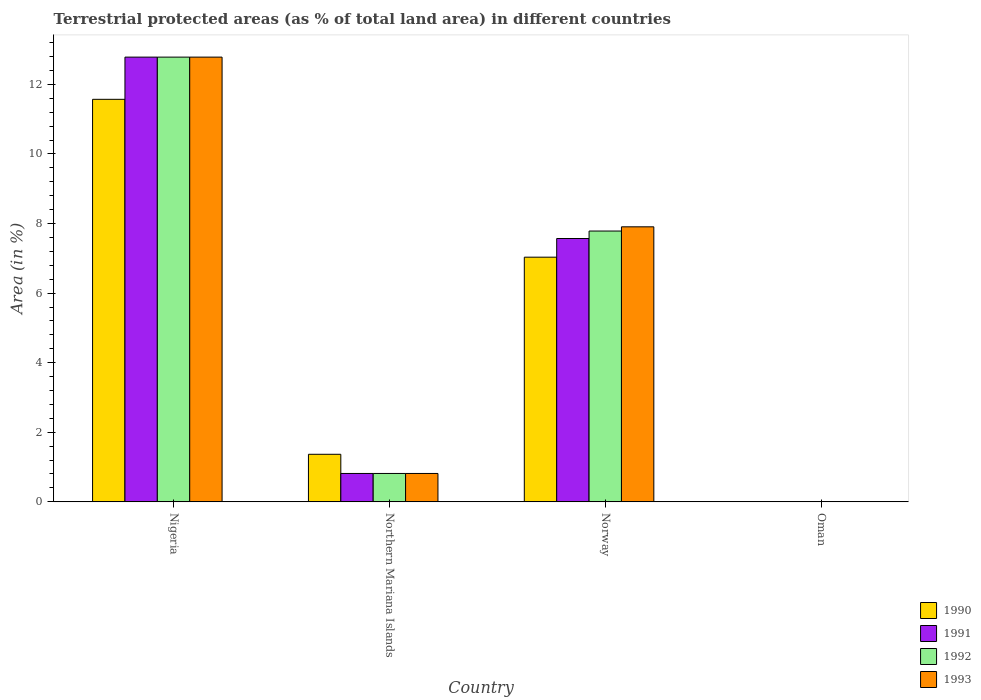How many groups of bars are there?
Keep it short and to the point. 4. Are the number of bars per tick equal to the number of legend labels?
Your response must be concise. Yes. What is the label of the 4th group of bars from the left?
Provide a short and direct response. Oman. What is the percentage of terrestrial protected land in 1992 in Northern Mariana Islands?
Provide a succinct answer. 0.82. Across all countries, what is the maximum percentage of terrestrial protected land in 1991?
Your response must be concise. 12.78. Across all countries, what is the minimum percentage of terrestrial protected land in 1990?
Your answer should be very brief. 0. In which country was the percentage of terrestrial protected land in 1991 maximum?
Give a very brief answer. Nigeria. In which country was the percentage of terrestrial protected land in 1991 minimum?
Offer a very short reply. Oman. What is the total percentage of terrestrial protected land in 1991 in the graph?
Give a very brief answer. 21.17. What is the difference between the percentage of terrestrial protected land in 1992 in Norway and that in Oman?
Offer a very short reply. 7.78. What is the difference between the percentage of terrestrial protected land in 1993 in Oman and the percentage of terrestrial protected land in 1992 in Northern Mariana Islands?
Offer a very short reply. -0.81. What is the average percentage of terrestrial protected land in 1991 per country?
Your response must be concise. 5.29. What is the difference between the percentage of terrestrial protected land of/in 1991 and percentage of terrestrial protected land of/in 1993 in Norway?
Provide a short and direct response. -0.34. In how many countries, is the percentage of terrestrial protected land in 1993 greater than 1.2000000000000002 %?
Make the answer very short. 2. What is the ratio of the percentage of terrestrial protected land in 1991 in Northern Mariana Islands to that in Oman?
Ensure brevity in your answer.  508.17. What is the difference between the highest and the second highest percentage of terrestrial protected land in 1993?
Offer a terse response. -11.97. What is the difference between the highest and the lowest percentage of terrestrial protected land in 1993?
Provide a succinct answer. 12.78. What does the 1st bar from the left in Oman represents?
Offer a very short reply. 1990. What does the 2nd bar from the right in Nigeria represents?
Your answer should be very brief. 1992. How many bars are there?
Your answer should be very brief. 16. Are all the bars in the graph horizontal?
Give a very brief answer. No. How many countries are there in the graph?
Keep it short and to the point. 4. Does the graph contain grids?
Keep it short and to the point. No. How many legend labels are there?
Offer a terse response. 4. How are the legend labels stacked?
Offer a very short reply. Vertical. What is the title of the graph?
Provide a short and direct response. Terrestrial protected areas (as % of total land area) in different countries. Does "1973" appear as one of the legend labels in the graph?
Your response must be concise. No. What is the label or title of the Y-axis?
Ensure brevity in your answer.  Area (in %). What is the Area (in %) in 1990 in Nigeria?
Offer a terse response. 11.57. What is the Area (in %) of 1991 in Nigeria?
Offer a very short reply. 12.78. What is the Area (in %) in 1992 in Nigeria?
Your answer should be very brief. 12.78. What is the Area (in %) of 1993 in Nigeria?
Offer a very short reply. 12.78. What is the Area (in %) of 1990 in Northern Mariana Islands?
Your response must be concise. 1.37. What is the Area (in %) in 1991 in Northern Mariana Islands?
Provide a succinct answer. 0.82. What is the Area (in %) in 1992 in Northern Mariana Islands?
Your answer should be very brief. 0.82. What is the Area (in %) of 1993 in Northern Mariana Islands?
Ensure brevity in your answer.  0.82. What is the Area (in %) in 1990 in Norway?
Make the answer very short. 7.03. What is the Area (in %) in 1991 in Norway?
Your answer should be compact. 7.57. What is the Area (in %) of 1992 in Norway?
Give a very brief answer. 7.78. What is the Area (in %) of 1993 in Norway?
Your answer should be compact. 7.9. What is the Area (in %) of 1990 in Oman?
Keep it short and to the point. 0. What is the Area (in %) in 1991 in Oman?
Offer a very short reply. 0. What is the Area (in %) in 1992 in Oman?
Your answer should be compact. 0. What is the Area (in %) of 1993 in Oman?
Ensure brevity in your answer.  0. Across all countries, what is the maximum Area (in %) of 1990?
Ensure brevity in your answer.  11.57. Across all countries, what is the maximum Area (in %) in 1991?
Your response must be concise. 12.78. Across all countries, what is the maximum Area (in %) of 1992?
Your answer should be compact. 12.78. Across all countries, what is the maximum Area (in %) of 1993?
Make the answer very short. 12.78. Across all countries, what is the minimum Area (in %) in 1990?
Offer a terse response. 0. Across all countries, what is the minimum Area (in %) in 1991?
Provide a short and direct response. 0. Across all countries, what is the minimum Area (in %) of 1992?
Keep it short and to the point. 0. Across all countries, what is the minimum Area (in %) in 1993?
Ensure brevity in your answer.  0. What is the total Area (in %) in 1990 in the graph?
Make the answer very short. 19.97. What is the total Area (in %) in 1991 in the graph?
Give a very brief answer. 21.17. What is the total Area (in %) of 1992 in the graph?
Your answer should be compact. 21.38. What is the total Area (in %) in 1993 in the graph?
Offer a terse response. 21.5. What is the difference between the Area (in %) in 1990 in Nigeria and that in Northern Mariana Islands?
Make the answer very short. 10.2. What is the difference between the Area (in %) of 1991 in Nigeria and that in Northern Mariana Islands?
Your answer should be compact. 11.97. What is the difference between the Area (in %) of 1992 in Nigeria and that in Northern Mariana Islands?
Ensure brevity in your answer.  11.97. What is the difference between the Area (in %) of 1993 in Nigeria and that in Northern Mariana Islands?
Ensure brevity in your answer.  11.97. What is the difference between the Area (in %) of 1990 in Nigeria and that in Norway?
Your response must be concise. 4.54. What is the difference between the Area (in %) of 1991 in Nigeria and that in Norway?
Make the answer very short. 5.21. What is the difference between the Area (in %) in 1992 in Nigeria and that in Norway?
Provide a short and direct response. 5. What is the difference between the Area (in %) in 1993 in Nigeria and that in Norway?
Offer a very short reply. 4.88. What is the difference between the Area (in %) in 1990 in Nigeria and that in Oman?
Provide a succinct answer. 11.57. What is the difference between the Area (in %) in 1991 in Nigeria and that in Oman?
Make the answer very short. 12.78. What is the difference between the Area (in %) in 1992 in Nigeria and that in Oman?
Ensure brevity in your answer.  12.78. What is the difference between the Area (in %) in 1993 in Nigeria and that in Oman?
Your response must be concise. 12.78. What is the difference between the Area (in %) in 1990 in Northern Mariana Islands and that in Norway?
Your answer should be compact. -5.67. What is the difference between the Area (in %) of 1991 in Northern Mariana Islands and that in Norway?
Offer a terse response. -6.75. What is the difference between the Area (in %) in 1992 in Northern Mariana Islands and that in Norway?
Your answer should be very brief. -6.97. What is the difference between the Area (in %) of 1993 in Northern Mariana Islands and that in Norway?
Give a very brief answer. -7.09. What is the difference between the Area (in %) of 1990 in Northern Mariana Islands and that in Oman?
Your response must be concise. 1.36. What is the difference between the Area (in %) in 1991 in Northern Mariana Islands and that in Oman?
Keep it short and to the point. 0.81. What is the difference between the Area (in %) in 1992 in Northern Mariana Islands and that in Oman?
Ensure brevity in your answer.  0.81. What is the difference between the Area (in %) in 1993 in Northern Mariana Islands and that in Oman?
Provide a short and direct response. 0.81. What is the difference between the Area (in %) in 1990 in Norway and that in Oman?
Offer a terse response. 7.03. What is the difference between the Area (in %) of 1991 in Norway and that in Oman?
Provide a short and direct response. 7.57. What is the difference between the Area (in %) in 1992 in Norway and that in Oman?
Make the answer very short. 7.78. What is the difference between the Area (in %) in 1993 in Norway and that in Oman?
Offer a very short reply. 7.9. What is the difference between the Area (in %) in 1990 in Nigeria and the Area (in %) in 1991 in Northern Mariana Islands?
Ensure brevity in your answer.  10.75. What is the difference between the Area (in %) of 1990 in Nigeria and the Area (in %) of 1992 in Northern Mariana Islands?
Your response must be concise. 10.75. What is the difference between the Area (in %) of 1990 in Nigeria and the Area (in %) of 1993 in Northern Mariana Islands?
Offer a very short reply. 10.75. What is the difference between the Area (in %) of 1991 in Nigeria and the Area (in %) of 1992 in Northern Mariana Islands?
Keep it short and to the point. 11.97. What is the difference between the Area (in %) of 1991 in Nigeria and the Area (in %) of 1993 in Northern Mariana Islands?
Give a very brief answer. 11.97. What is the difference between the Area (in %) of 1992 in Nigeria and the Area (in %) of 1993 in Northern Mariana Islands?
Provide a short and direct response. 11.97. What is the difference between the Area (in %) in 1990 in Nigeria and the Area (in %) in 1991 in Norway?
Provide a short and direct response. 4. What is the difference between the Area (in %) in 1990 in Nigeria and the Area (in %) in 1992 in Norway?
Your response must be concise. 3.79. What is the difference between the Area (in %) of 1990 in Nigeria and the Area (in %) of 1993 in Norway?
Ensure brevity in your answer.  3.66. What is the difference between the Area (in %) of 1991 in Nigeria and the Area (in %) of 1992 in Norway?
Offer a very short reply. 5. What is the difference between the Area (in %) of 1991 in Nigeria and the Area (in %) of 1993 in Norway?
Ensure brevity in your answer.  4.88. What is the difference between the Area (in %) of 1992 in Nigeria and the Area (in %) of 1993 in Norway?
Keep it short and to the point. 4.88. What is the difference between the Area (in %) of 1990 in Nigeria and the Area (in %) of 1991 in Oman?
Provide a succinct answer. 11.57. What is the difference between the Area (in %) in 1990 in Nigeria and the Area (in %) in 1992 in Oman?
Give a very brief answer. 11.57. What is the difference between the Area (in %) of 1990 in Nigeria and the Area (in %) of 1993 in Oman?
Offer a terse response. 11.57. What is the difference between the Area (in %) in 1991 in Nigeria and the Area (in %) in 1992 in Oman?
Provide a short and direct response. 12.78. What is the difference between the Area (in %) of 1991 in Nigeria and the Area (in %) of 1993 in Oman?
Give a very brief answer. 12.78. What is the difference between the Area (in %) of 1992 in Nigeria and the Area (in %) of 1993 in Oman?
Your answer should be very brief. 12.78. What is the difference between the Area (in %) in 1990 in Northern Mariana Islands and the Area (in %) in 1991 in Norway?
Provide a short and direct response. -6.2. What is the difference between the Area (in %) in 1990 in Northern Mariana Islands and the Area (in %) in 1992 in Norway?
Keep it short and to the point. -6.42. What is the difference between the Area (in %) of 1990 in Northern Mariana Islands and the Area (in %) of 1993 in Norway?
Provide a short and direct response. -6.54. What is the difference between the Area (in %) in 1991 in Northern Mariana Islands and the Area (in %) in 1992 in Norway?
Your answer should be very brief. -6.97. What is the difference between the Area (in %) of 1991 in Northern Mariana Islands and the Area (in %) of 1993 in Norway?
Your response must be concise. -7.09. What is the difference between the Area (in %) in 1992 in Northern Mariana Islands and the Area (in %) in 1993 in Norway?
Ensure brevity in your answer.  -7.09. What is the difference between the Area (in %) of 1990 in Northern Mariana Islands and the Area (in %) of 1991 in Oman?
Ensure brevity in your answer.  1.36. What is the difference between the Area (in %) in 1990 in Northern Mariana Islands and the Area (in %) in 1992 in Oman?
Offer a very short reply. 1.36. What is the difference between the Area (in %) in 1990 in Northern Mariana Islands and the Area (in %) in 1993 in Oman?
Your answer should be compact. 1.36. What is the difference between the Area (in %) of 1991 in Northern Mariana Islands and the Area (in %) of 1992 in Oman?
Offer a very short reply. 0.81. What is the difference between the Area (in %) in 1991 in Northern Mariana Islands and the Area (in %) in 1993 in Oman?
Offer a terse response. 0.81. What is the difference between the Area (in %) in 1992 in Northern Mariana Islands and the Area (in %) in 1993 in Oman?
Your response must be concise. 0.81. What is the difference between the Area (in %) in 1990 in Norway and the Area (in %) in 1991 in Oman?
Offer a terse response. 7.03. What is the difference between the Area (in %) of 1990 in Norway and the Area (in %) of 1992 in Oman?
Offer a terse response. 7.03. What is the difference between the Area (in %) in 1990 in Norway and the Area (in %) in 1993 in Oman?
Give a very brief answer. 7.03. What is the difference between the Area (in %) of 1991 in Norway and the Area (in %) of 1992 in Oman?
Your response must be concise. 7.57. What is the difference between the Area (in %) in 1991 in Norway and the Area (in %) in 1993 in Oman?
Offer a very short reply. 7.57. What is the difference between the Area (in %) in 1992 in Norway and the Area (in %) in 1993 in Oman?
Provide a succinct answer. 7.78. What is the average Area (in %) of 1990 per country?
Your answer should be compact. 4.99. What is the average Area (in %) of 1991 per country?
Offer a terse response. 5.29. What is the average Area (in %) of 1992 per country?
Your answer should be very brief. 5.35. What is the average Area (in %) in 1993 per country?
Give a very brief answer. 5.38. What is the difference between the Area (in %) of 1990 and Area (in %) of 1991 in Nigeria?
Make the answer very short. -1.21. What is the difference between the Area (in %) of 1990 and Area (in %) of 1992 in Nigeria?
Keep it short and to the point. -1.21. What is the difference between the Area (in %) of 1990 and Area (in %) of 1993 in Nigeria?
Your answer should be very brief. -1.21. What is the difference between the Area (in %) in 1991 and Area (in %) in 1993 in Nigeria?
Offer a very short reply. 0. What is the difference between the Area (in %) of 1990 and Area (in %) of 1991 in Northern Mariana Islands?
Offer a terse response. 0.55. What is the difference between the Area (in %) of 1990 and Area (in %) of 1992 in Northern Mariana Islands?
Ensure brevity in your answer.  0.55. What is the difference between the Area (in %) of 1990 and Area (in %) of 1993 in Northern Mariana Islands?
Offer a very short reply. 0.55. What is the difference between the Area (in %) of 1991 and Area (in %) of 1993 in Northern Mariana Islands?
Your answer should be very brief. 0. What is the difference between the Area (in %) of 1992 and Area (in %) of 1993 in Northern Mariana Islands?
Your answer should be compact. 0. What is the difference between the Area (in %) in 1990 and Area (in %) in 1991 in Norway?
Keep it short and to the point. -0.54. What is the difference between the Area (in %) of 1990 and Area (in %) of 1992 in Norway?
Provide a short and direct response. -0.75. What is the difference between the Area (in %) in 1990 and Area (in %) in 1993 in Norway?
Make the answer very short. -0.87. What is the difference between the Area (in %) of 1991 and Area (in %) of 1992 in Norway?
Ensure brevity in your answer.  -0.21. What is the difference between the Area (in %) of 1991 and Area (in %) of 1993 in Norway?
Give a very brief answer. -0.34. What is the difference between the Area (in %) in 1992 and Area (in %) in 1993 in Norway?
Offer a very short reply. -0.12. What is the difference between the Area (in %) in 1990 and Area (in %) in 1991 in Oman?
Ensure brevity in your answer.  0. What is the ratio of the Area (in %) in 1990 in Nigeria to that in Northern Mariana Islands?
Your answer should be compact. 8.47. What is the ratio of the Area (in %) of 1991 in Nigeria to that in Northern Mariana Islands?
Your answer should be compact. 15.68. What is the ratio of the Area (in %) in 1992 in Nigeria to that in Northern Mariana Islands?
Keep it short and to the point. 15.68. What is the ratio of the Area (in %) in 1993 in Nigeria to that in Northern Mariana Islands?
Make the answer very short. 15.68. What is the ratio of the Area (in %) in 1990 in Nigeria to that in Norway?
Provide a succinct answer. 1.65. What is the ratio of the Area (in %) of 1991 in Nigeria to that in Norway?
Offer a very short reply. 1.69. What is the ratio of the Area (in %) in 1992 in Nigeria to that in Norway?
Offer a very short reply. 1.64. What is the ratio of the Area (in %) of 1993 in Nigeria to that in Norway?
Make the answer very short. 1.62. What is the ratio of the Area (in %) in 1990 in Nigeria to that in Oman?
Ensure brevity in your answer.  7210.59. What is the ratio of the Area (in %) of 1991 in Nigeria to that in Oman?
Your answer should be compact. 7967.56. What is the ratio of the Area (in %) of 1992 in Nigeria to that in Oman?
Your response must be concise. 7967.56. What is the ratio of the Area (in %) in 1993 in Nigeria to that in Oman?
Offer a terse response. 7967.56. What is the ratio of the Area (in %) of 1990 in Northern Mariana Islands to that in Norway?
Your response must be concise. 0.19. What is the ratio of the Area (in %) of 1991 in Northern Mariana Islands to that in Norway?
Ensure brevity in your answer.  0.11. What is the ratio of the Area (in %) in 1992 in Northern Mariana Islands to that in Norway?
Ensure brevity in your answer.  0.1. What is the ratio of the Area (in %) of 1993 in Northern Mariana Islands to that in Norway?
Ensure brevity in your answer.  0.1. What is the ratio of the Area (in %) in 1990 in Northern Mariana Islands to that in Oman?
Make the answer very short. 851.6. What is the ratio of the Area (in %) of 1991 in Northern Mariana Islands to that in Oman?
Your response must be concise. 508.17. What is the ratio of the Area (in %) of 1992 in Northern Mariana Islands to that in Oman?
Make the answer very short. 508.17. What is the ratio of the Area (in %) of 1993 in Northern Mariana Islands to that in Oman?
Provide a short and direct response. 508.17. What is the ratio of the Area (in %) in 1990 in Norway to that in Oman?
Make the answer very short. 4382.71. What is the ratio of the Area (in %) of 1991 in Norway to that in Oman?
Give a very brief answer. 4717.71. What is the ratio of the Area (in %) in 1992 in Norway to that in Oman?
Your answer should be very brief. 4851.36. What is the ratio of the Area (in %) in 1993 in Norway to that in Oman?
Offer a terse response. 4927.05. What is the difference between the highest and the second highest Area (in %) in 1990?
Provide a short and direct response. 4.54. What is the difference between the highest and the second highest Area (in %) of 1991?
Provide a succinct answer. 5.21. What is the difference between the highest and the second highest Area (in %) of 1992?
Keep it short and to the point. 5. What is the difference between the highest and the second highest Area (in %) of 1993?
Provide a short and direct response. 4.88. What is the difference between the highest and the lowest Area (in %) of 1990?
Offer a terse response. 11.57. What is the difference between the highest and the lowest Area (in %) of 1991?
Provide a succinct answer. 12.78. What is the difference between the highest and the lowest Area (in %) in 1992?
Your answer should be very brief. 12.78. What is the difference between the highest and the lowest Area (in %) of 1993?
Keep it short and to the point. 12.78. 